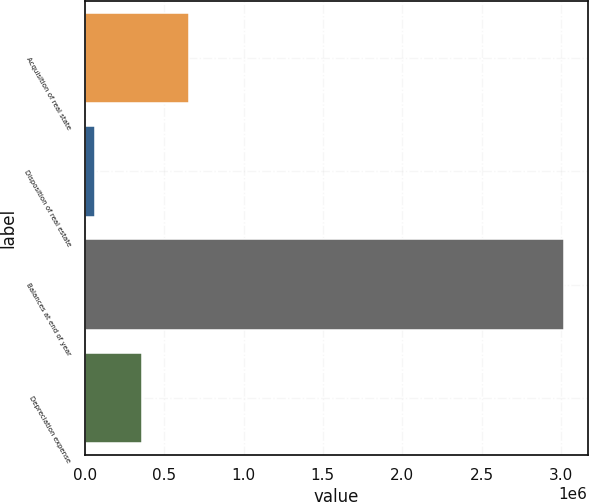<chart> <loc_0><loc_0><loc_500><loc_500><bar_chart><fcel>Acquisition of real state<fcel>Disposition of real estate<fcel>Balances at end of year<fcel>Depreciation expense<nl><fcel>653490<fcel>62497<fcel>3.01746e+06<fcel>357993<nl></chart> 